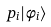<formula> <loc_0><loc_0><loc_500><loc_500>p _ { i } | \phi _ { i } \rangle</formula> 